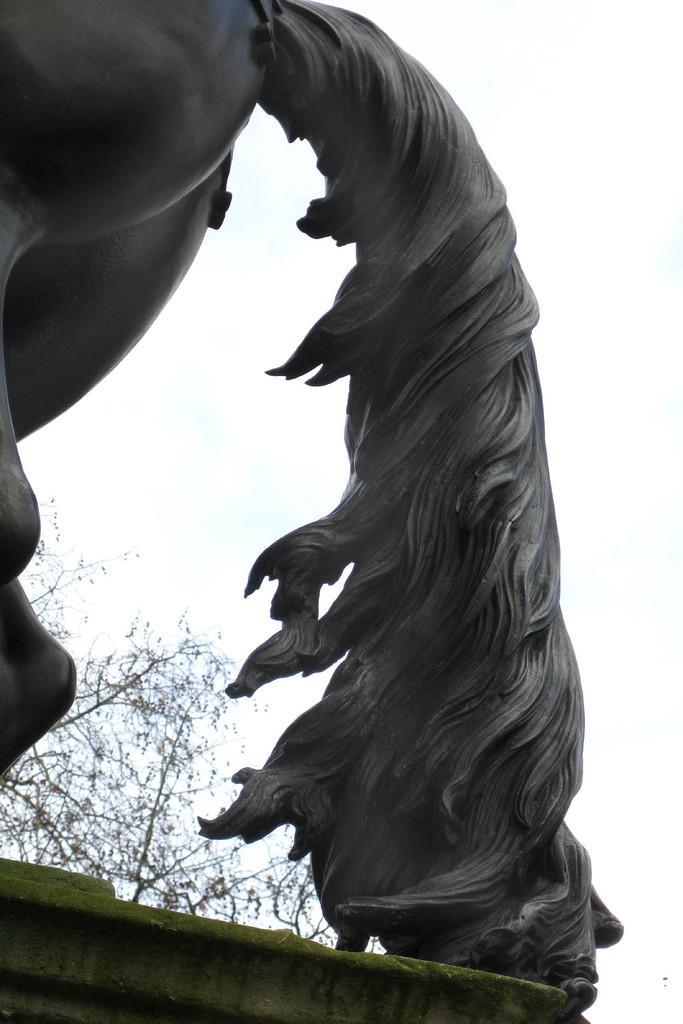Describe this image in one or two sentences. In this image we can see a sculpture of an animal, also we can see a tree and the sky. 